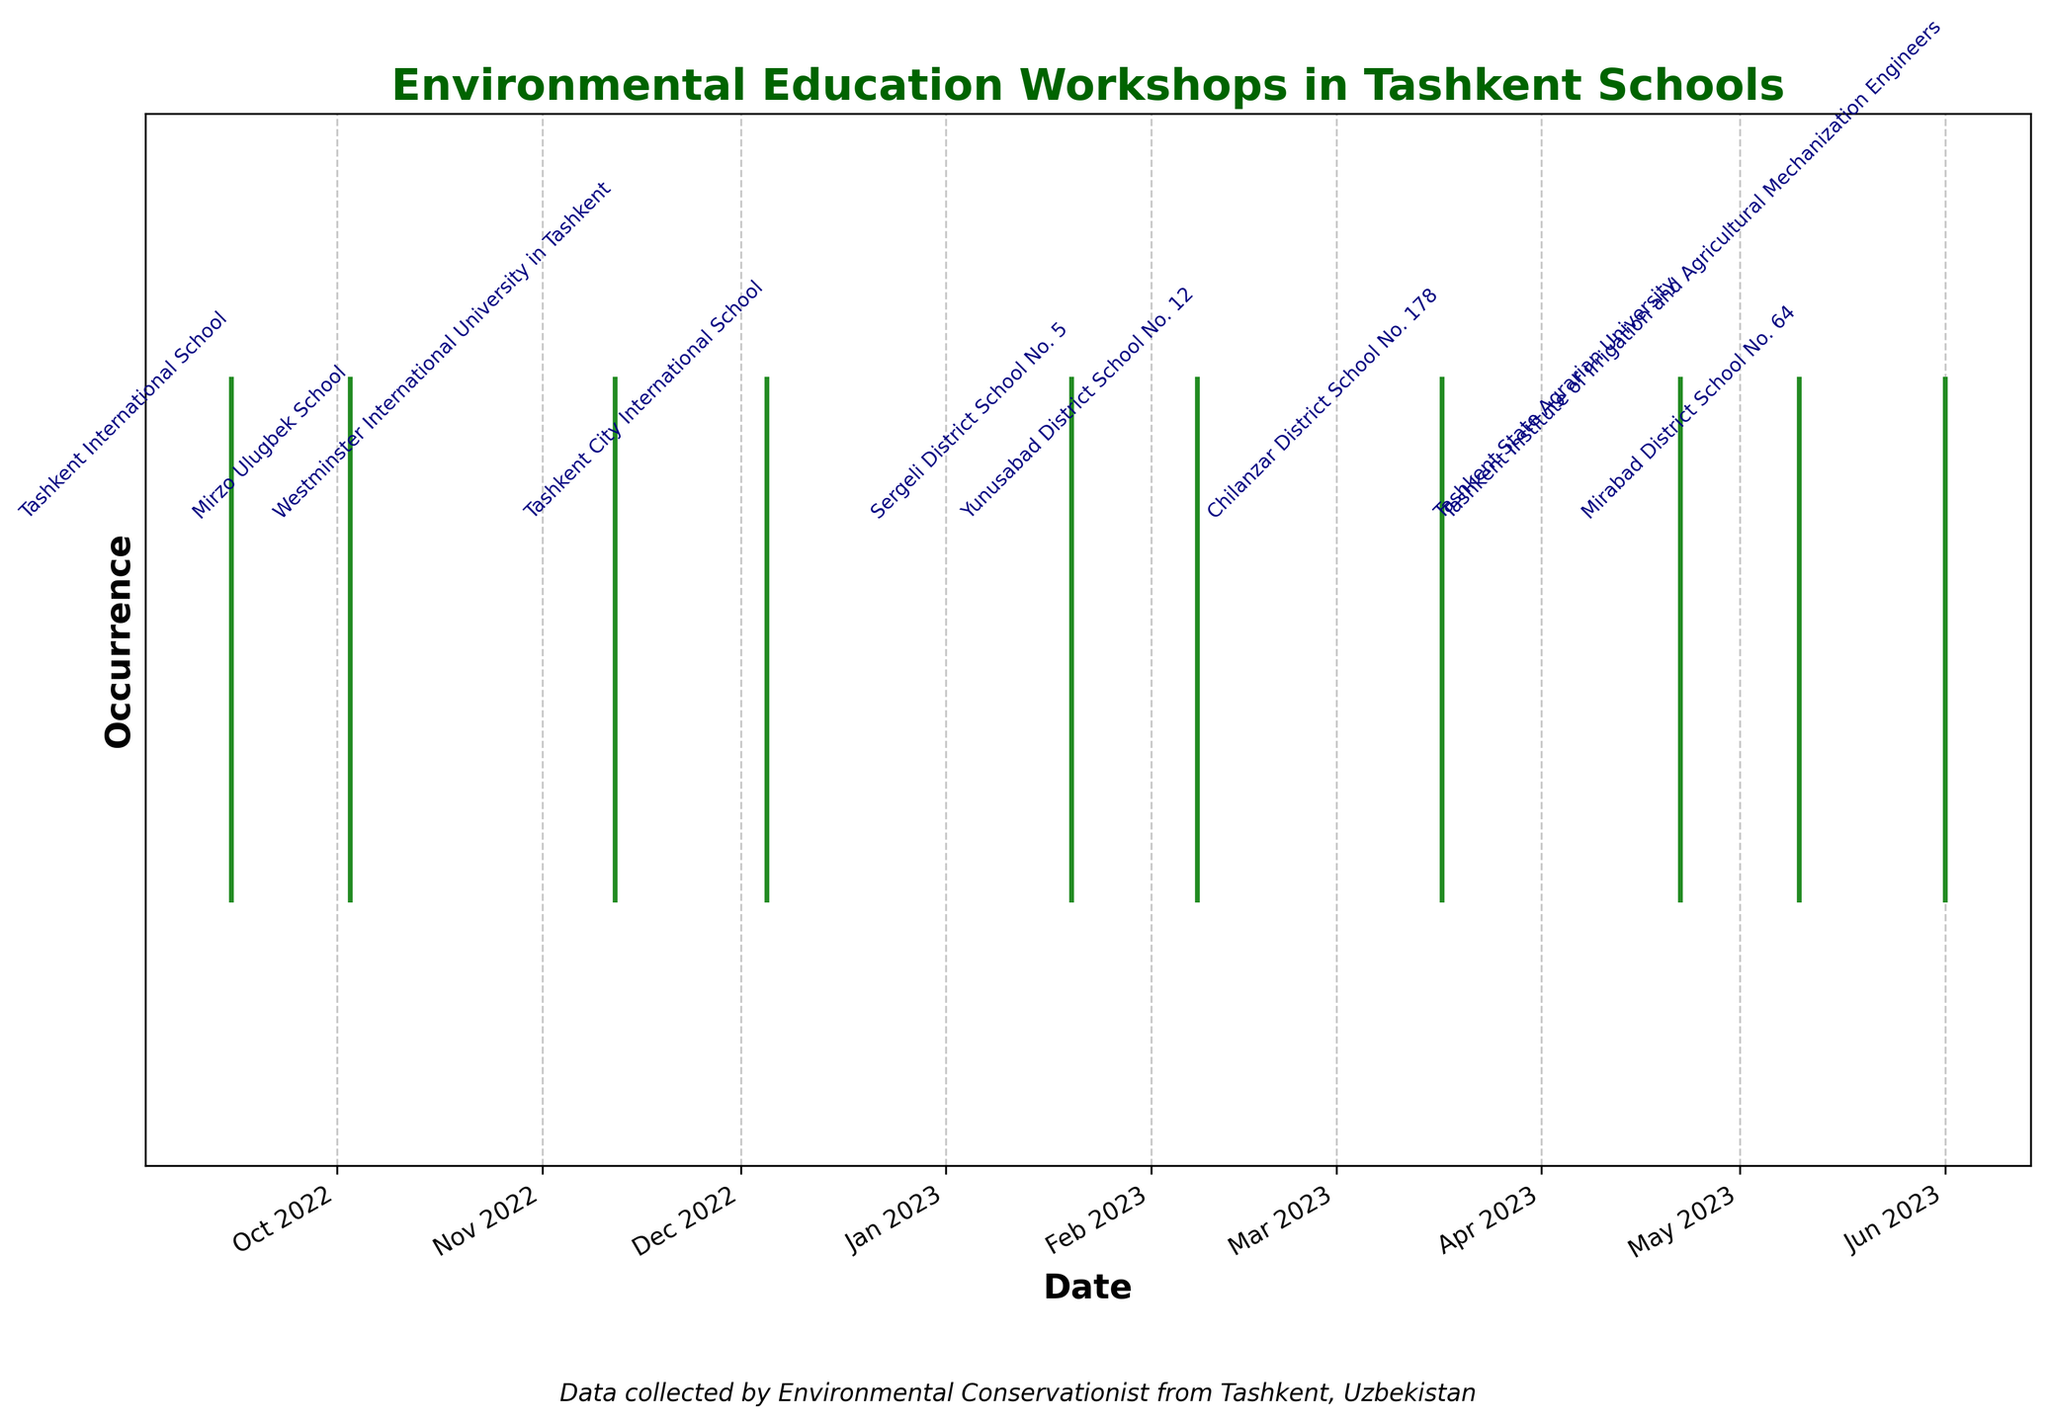When was the first environmental education workshop held according to the plot? The first event occurred on the leftmost point of the eventplot. It indicates the earliest date among all the plotted events.
Answer: September 15, 2022 How many events were held in the year 2022? By looking at the dates on the x-axis, count the number of events within the range that corresponds to the year 2022.
Answer: 4 Which school had an environmental education workshop in April? Identify the event point that corresponds to April on the x-axis and then check the annotation near that point for the school's name.
Answer: Tashkent State Agrarian University What is the range of months during which the workshops were held? Identify the earliest and the latest dates on the eventplot. These will give the range of months during which the events occurred.
Answer: September 2022 - June 2023 How many environmental education workshops were held in total? Count the number of event points displayed on the plot.
Answer: 10 Which month had the highest number of workshops held? Check the x-axis for the month with the most event points plotted on it.
Answer: No month had more than one event; they were evenly distributed What is the time difference between the first and the last workshop dates? Calculate the difference in dates between the first event (September 15, 2022) and the last event (June 1, 2023).
Answer: About 8.5 months Was there any school that had more than one workshop during the period? Look at the annotations and count how many times each school name appears.
Answer: No During which season did the majority of the workshops occur? Identify the season by observing the clustering of months in the plot. Fall corresponds to September-November, Winter to December-February, etc. Count the number of events per season.
Answer: Winter and Spring (4 events each) 